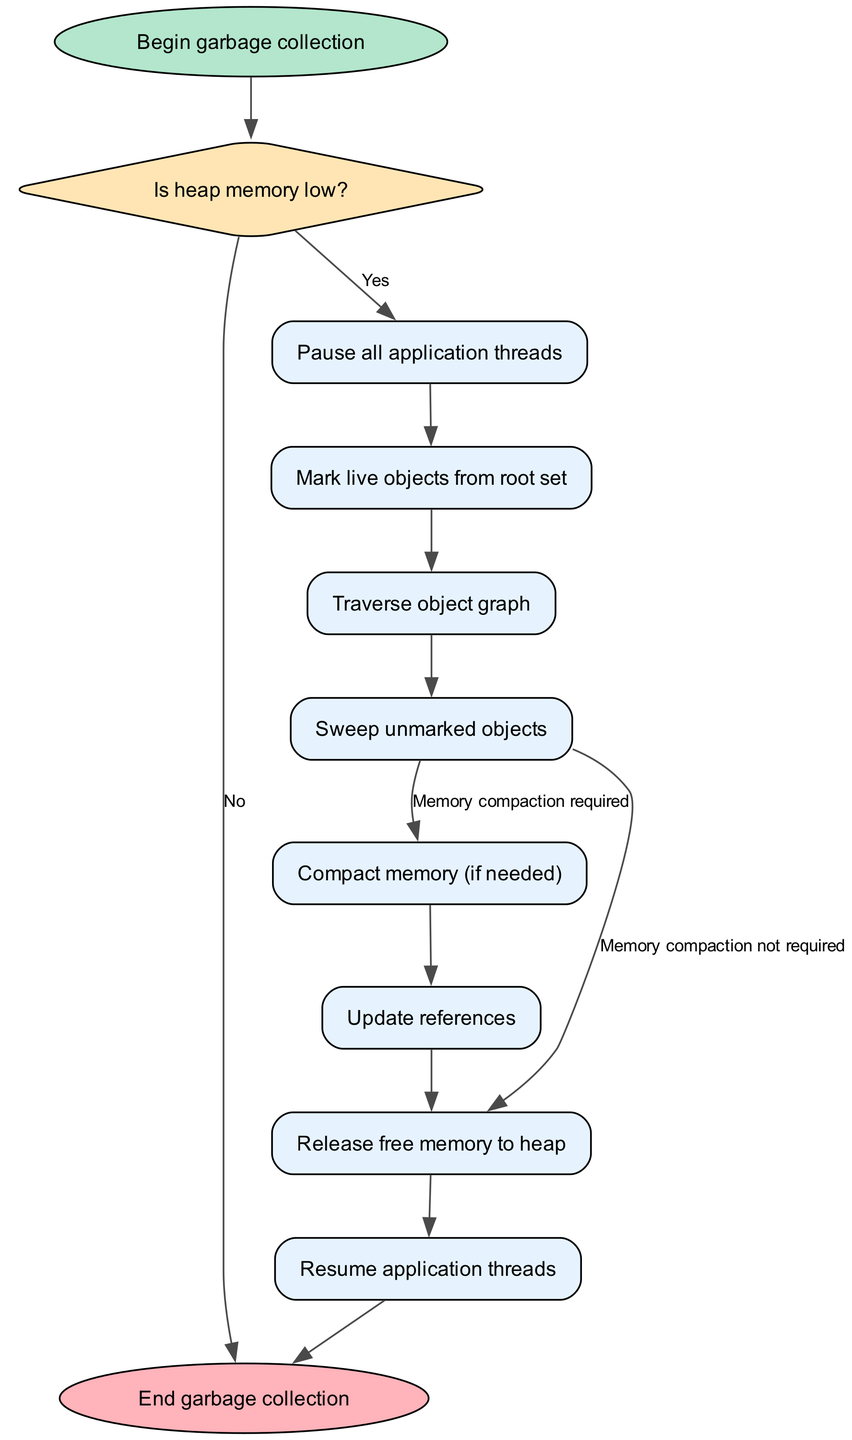What is the first step in the garbage collection process? The first step in the garbage collection process, as shown in the diagram, is "Begin garbage collection." This is the starting point of the flowchart where the workflow initiates.
Answer: Begin garbage collection What decision is made regarding heap memory? The diagram includes a decision node labeled "Is heap memory low?" This question is posed to determine if the garbage collection process needs to start, based on the current state of memory.
Answer: Is heap memory low? How many processes are involved after starting garbage collection? After the "Begin garbage collection" node, there are a series of process nodes that follow. There are six distinct process nodes ("process1" to "process8" excluding the decision node). Thus, there are six processes involved.
Answer: Six What happens if the heap memory is low? In the flowchart, if the decision "Is heap memory low?" is answered with "Yes," the next step is to "Pause all application threads." This action indicates that the program execution will be temporarily halted to perform garbage collection.
Answer: Pause all application threads What is the final stage of the garbage collection process? The last node in the flowchart indicates "End garbage collection." This shows that after all processes and cleanup actions are completed, the garbage collection cycle concludes with this step.
Answer: End garbage collection If memory compaction is not required, what is the next step after sweeping unmarked objects? The flowchart indicates that if memory compaction is not required, after "Sweep unmarked objects," the next step is to "Release free memory to heap." This signifies the process of returning available memory back to the heap for future use.
Answer: Release free memory to heap How many edges are connected to the decision node? The decision node "Is heap memory low?" has two outgoing edges: one leading to the "Pause all application threads" process for "Yes" and one leading to the "End garbage collection" process for "No." Therefore, there are two edges connected to this decision node.
Answer: Two What processes occur after traversing the object graph? After the "Traverse object graph" process, the next process outlined in the flowchart is "Sweep unmarked objects." This sequence follows logically as the traversal identifies objects and the sweeping phase collects those that are unmarked for cleanup.
Answer: Sweep unmarked objects 